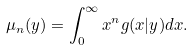<formula> <loc_0><loc_0><loc_500><loc_500>\mu _ { n } ( y ) = \int _ { 0 } ^ { \infty } x ^ { n } g ( x | y ) d x .</formula> 